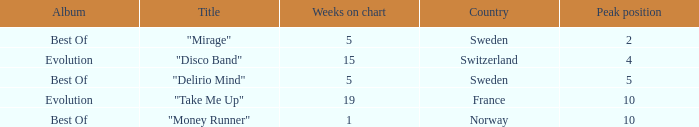What is the title of the single with the peak position of 10 and from France? "Take Me Up". 